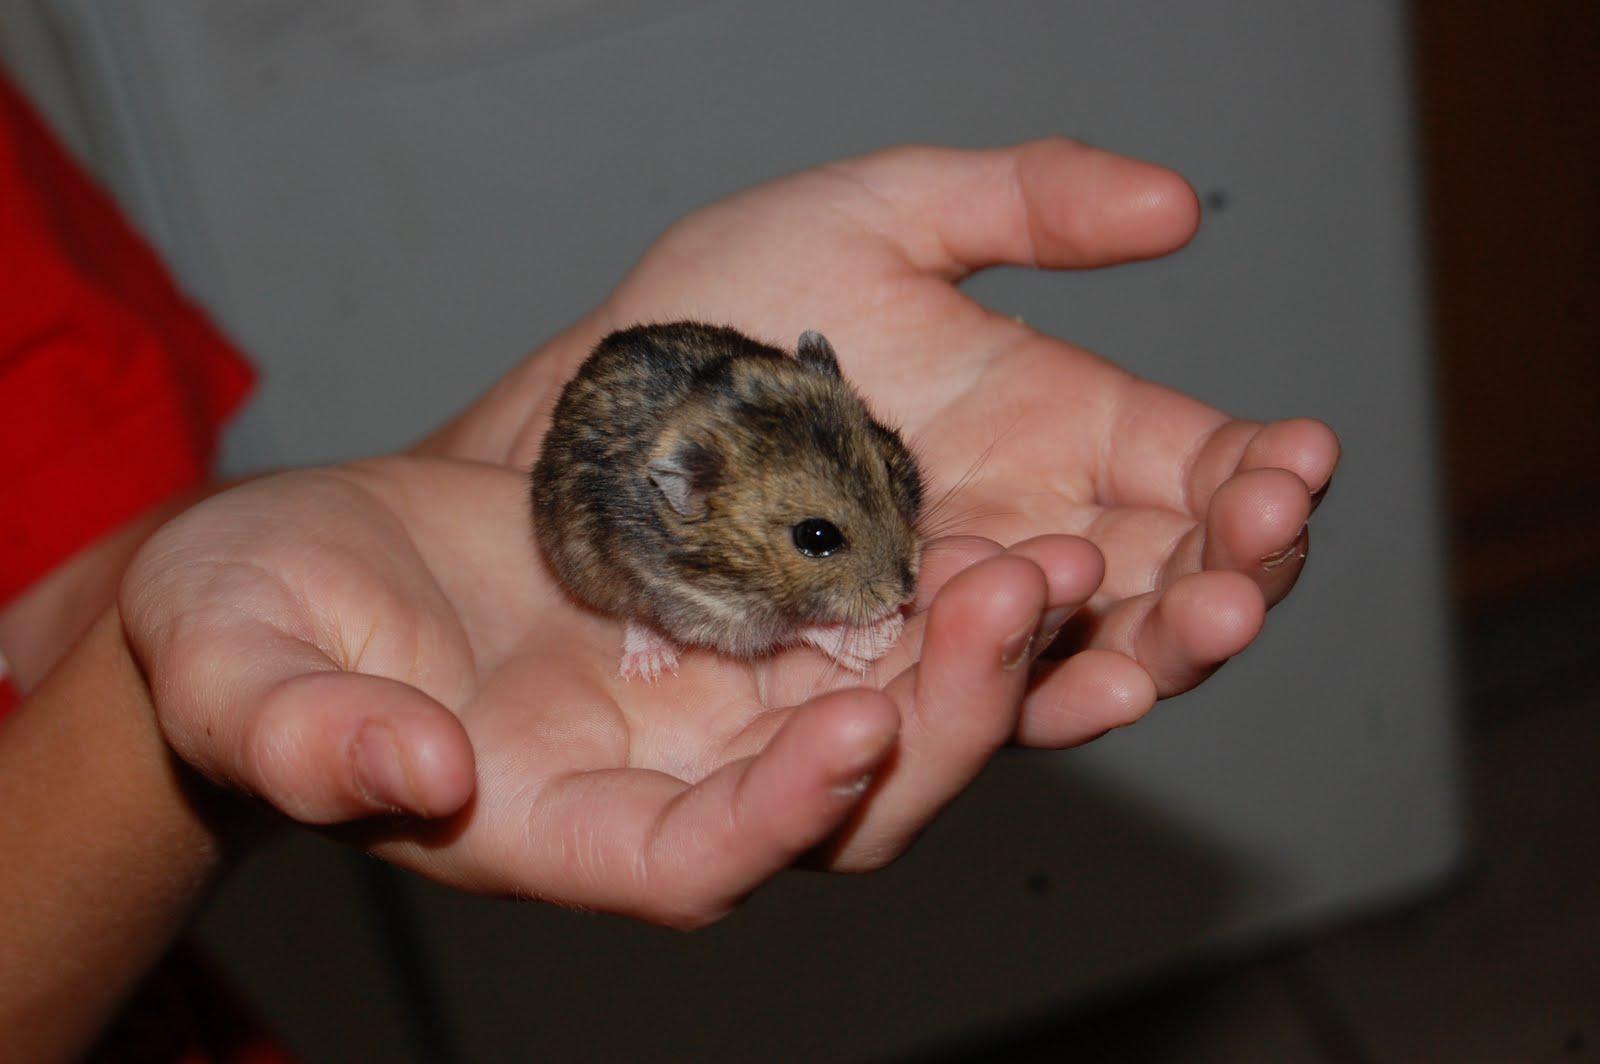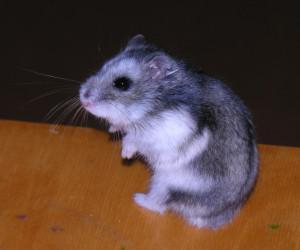The first image is the image on the left, the second image is the image on the right. Assess this claim about the two images: "Each image contains a single pet rodent, and one of the rodents is held in a pair of upturned hands.". Correct or not? Answer yes or no. Yes. The first image is the image on the left, the second image is the image on the right. For the images displayed, is the sentence "The right image contains a human touching a rodent." factually correct? Answer yes or no. No. 